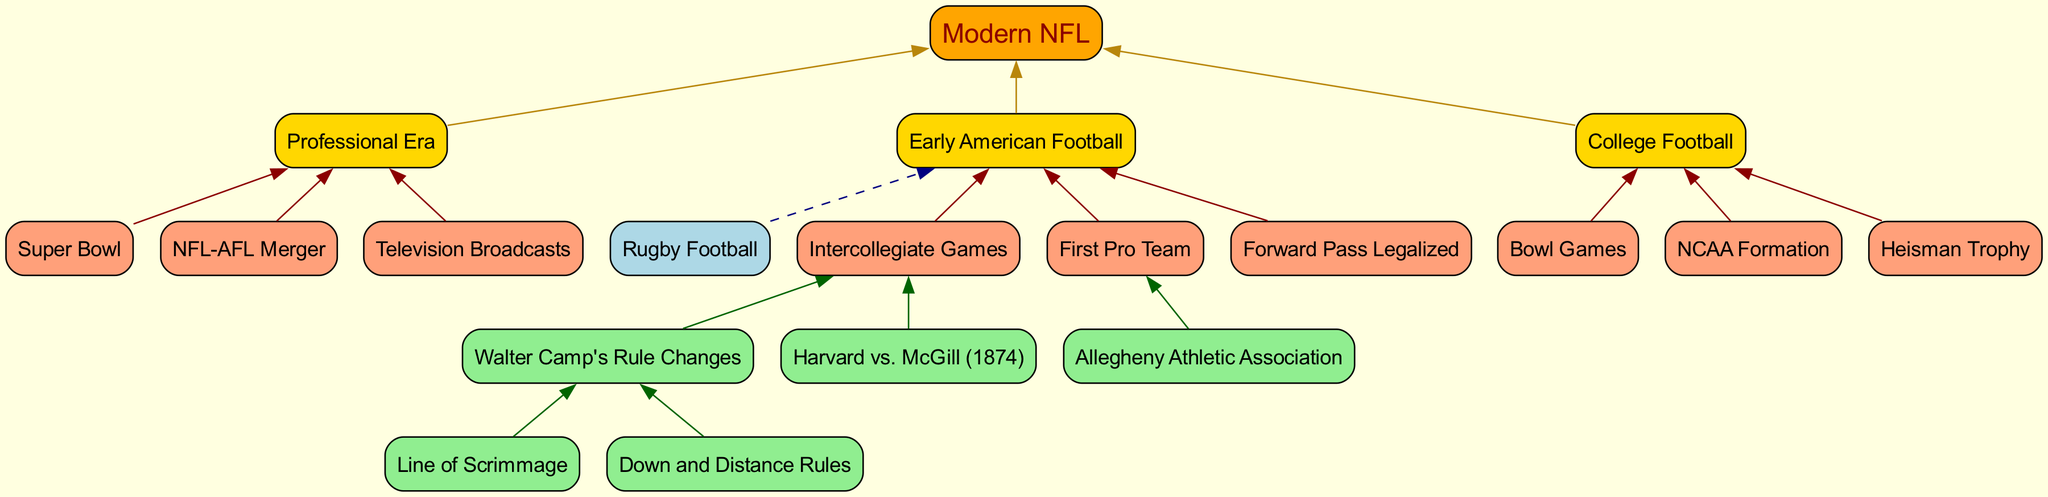What is at the root of the diagram? The root node of the diagram represents the final evolution of American football, which is depicted at the top of the flow chart. According to the data provided, this node is labeled as "Modern NFL".
Answer: Modern NFL How many level 1 nodes are there? The level 1 nodes represent the main divisions leading to the root node. The data specifies that there are three main categories under level 1: "Professional Era", "College Football", and "Early American Football". Thus, the number of level 1 nodes is three.
Answer: 3 Which node connects "Rugby Football" to "Early American Football"? The relationship between the nodes is indicated by an edge connecting "Rugby Football" to "Early American Football." The diagram shows that this connection is dashed, indicating a historical link. Thus, the direct connection is indicated by the upward flow from "Rugby Football" to "Early American Football".
Answer: Early American Football What are the children of "Professional Era"? The children nodes under "Professional Era" represent different developments during this era. According to the flow chart data, the three children nodes are "Super Bowl", "NFL-AFL Merger", and "Television Broadcasts".
Answer: Super Bowl, NFL-AFL Merger, Television Broadcasts How many children does the node "Intercollegiate Games" have? To determine the number of children for the node "Intercollegiate Games", we examine the level 3 data, which shows that it has two children: "Harvard vs. McGill (1874)" and "Walter Camp's Rule Changes". Therefore, the count of children for "Intercollegiate Games" is two.
Answer: 2 Which rule changes did Walter Camp introduce? The data specifies that Walter Camp's rule changes are directly connected to its children. Specifically, these changes include "Line of Scrimmage" and "Down and Distance Rules". Thus, the changes introduced by Walter Camp are directly listed under this node.
Answer: Line of Scrimmage, Down and Distance Rules What is the significance of "First Pro Team"? "First Pro Team" is a child of the "Early American Football" node and signifies the emergence of professional football in the early stages of the sport's evolution. The diagram identifies "Allegheny Athletic Association" as the first professional team, emphasizing its importance in the history of American football.
Answer: Allegheny Athletic Association Which node leads to the children "Bowl Games", "NCAA Formation", and "Heisman Trophy"? These children are associated with the higher category of "College Football", indicating the developments that shaped college football during its evolution. The flowchart makes it clear that they are linked directly to the "College Football" node as its offspring.
Answer: College Football What connects "Walter Camp's Rule Changes" to "Early American Football"? "Walter Camp's Rule Changes" is a child of "Intercollegiate Games", which itself is a child of "Early American Football". Therefore, there is a direct relationship flowing upwards from "Walter Camp's Rule Changes" through "Intercollegiate Games" to "Early American Football".
Answer: Early American Football 